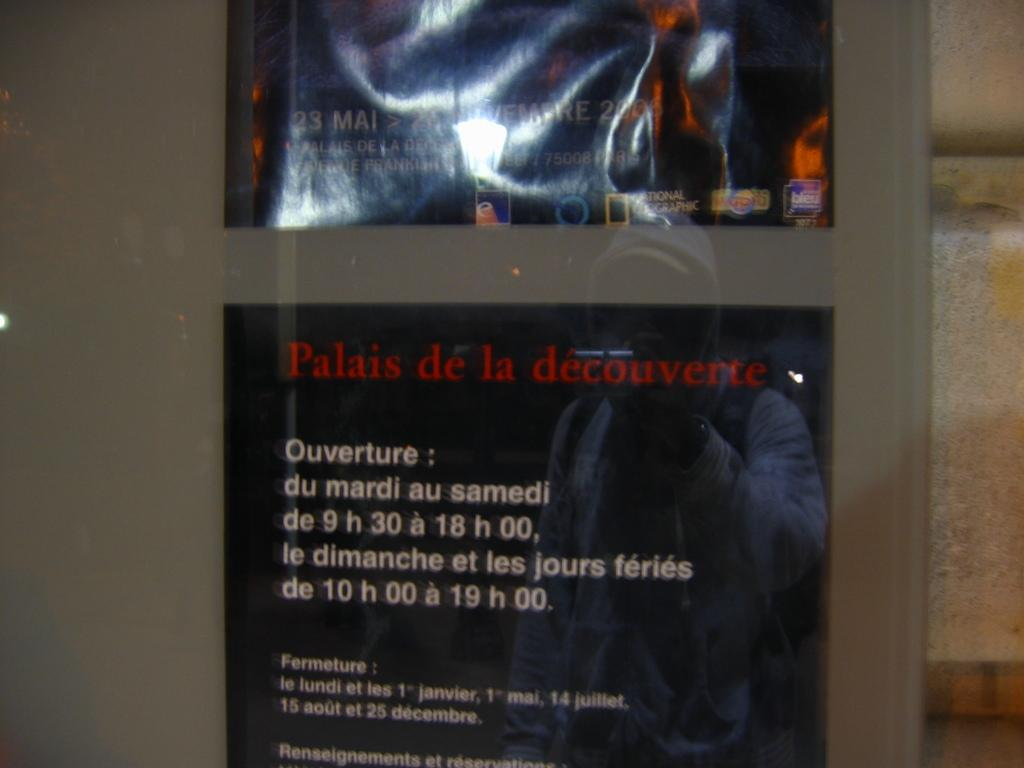What is depicted on the poster in the image? There is a poster with text in the image. What is the background of the image? There is a wall in the image. Can you describe the reflection in the image? There is a reflection of a person on the glass. How many bells are hanging from the wire in the image? There is no wire or bells present in the image. What type of visitor can be seen in the image? There is no visitor present in the image. 